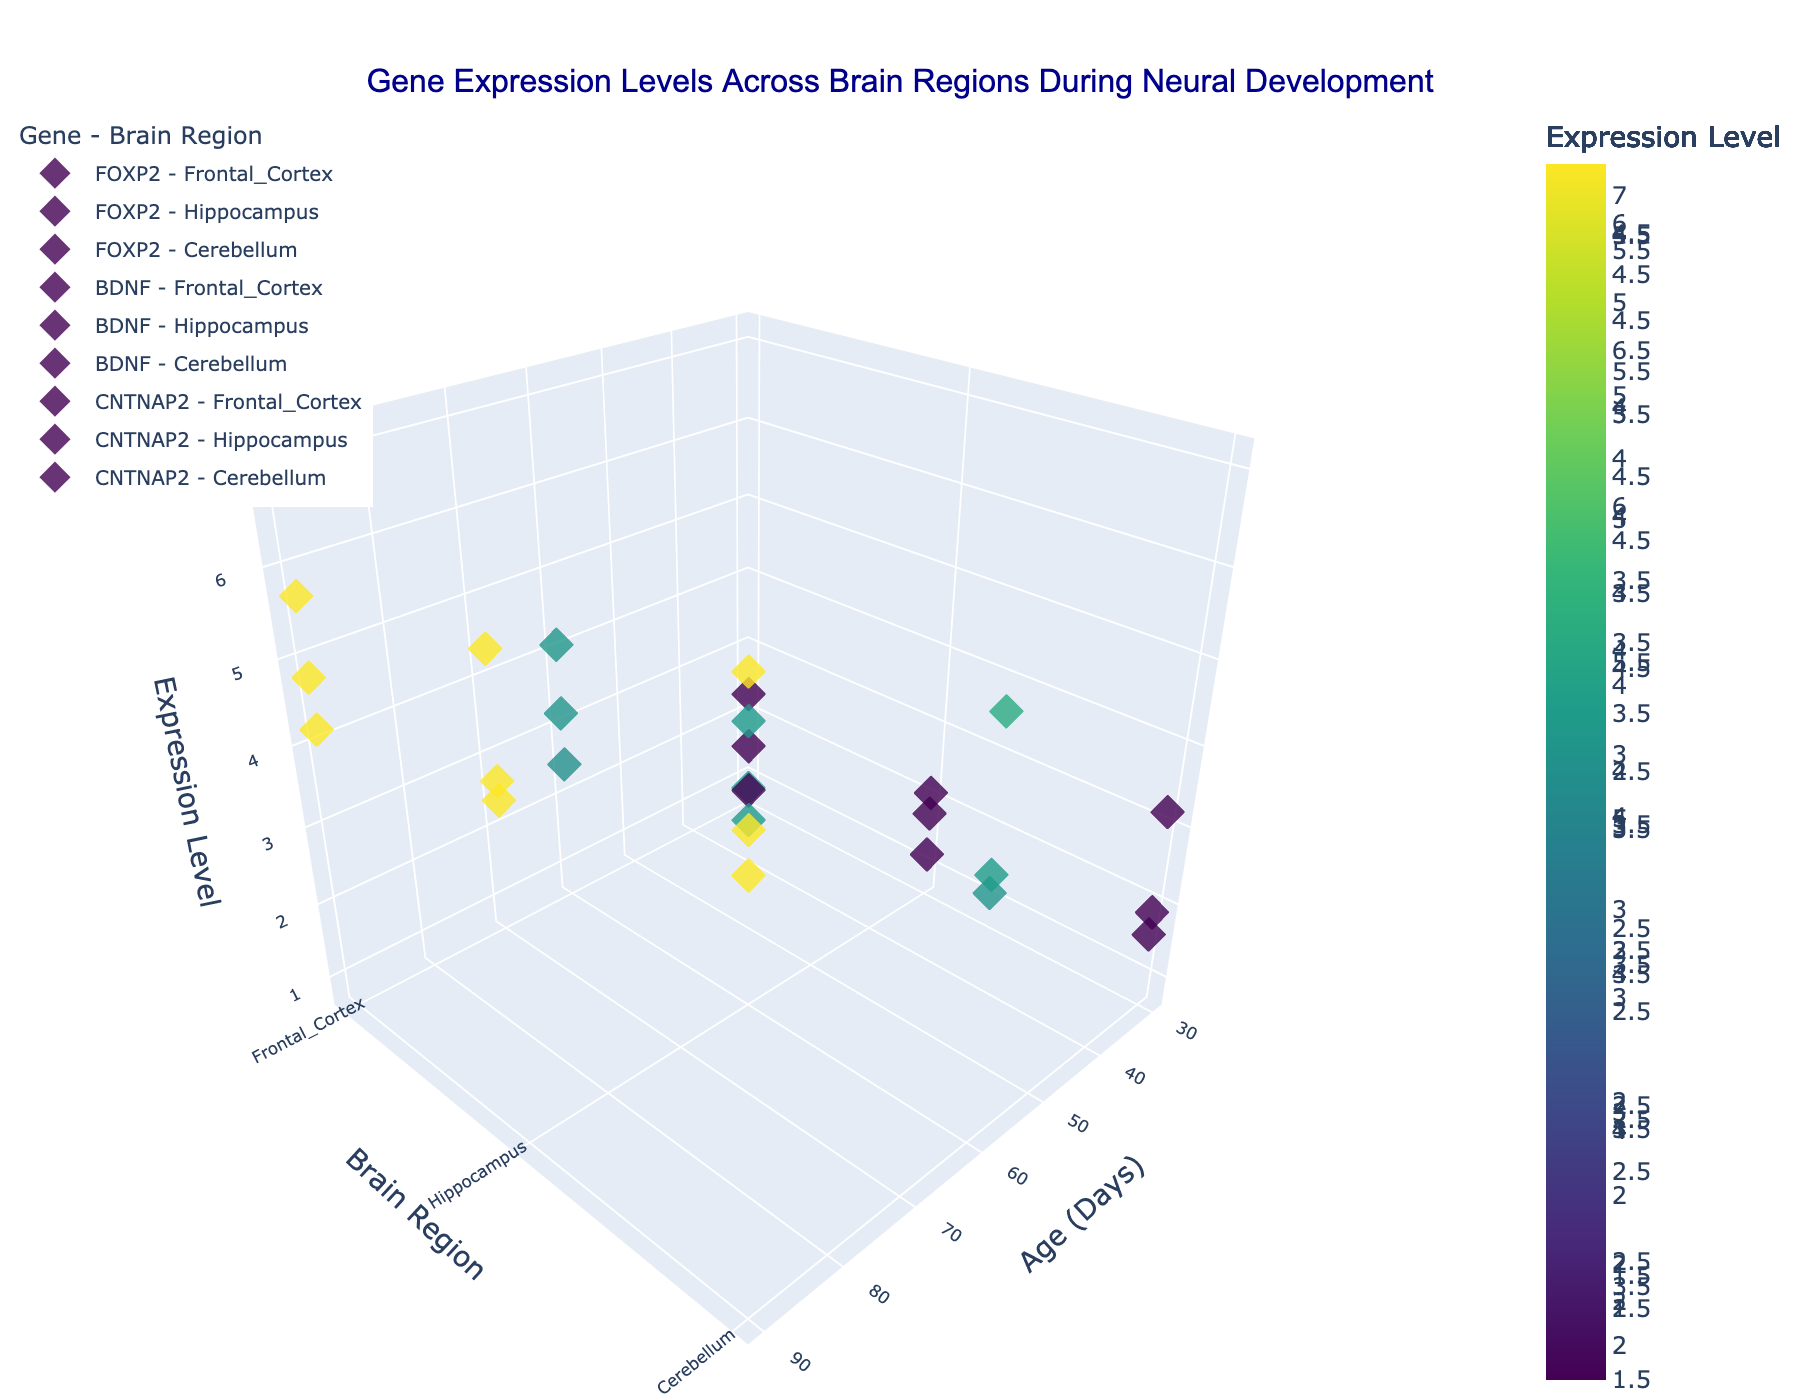what is the title of the figure? The title is usually placed at the top of the figure. In this case, it reads "Gene Expression Levels Across Brain Regions During Neural Development".
Answer: Gene Expression Levels Across Brain Regions During Neural Development What are the three brain regions displayed on the y-axis? The y-axis represents the brain regions. From the figure, the three brain regions are "Frontal Cortex", "Hippocampus", and "Cerebellum".
Answer: Frontal Cortex, Hippocampus, Cerebellum How does FOXP2 expression in the Frontal Cortex change with age? Looking at the markers for FOXP2 in the Frontal Cortex, we see the expression levels at 30 days, 60 days, and 90 days. These levels are 2.3, 4.1, and 5.7 respectively, showing an increasing trend.
Answer: Increases Which gene has the highest expression level in the Cerebellum at 90 days? We need to identify the point at Cerebellum at 90 days and compare the expression levels. FOXP2 has an expression of 7.1, BDNF has 5.4, and CNTNAP2 has 5.8. The highest value is for FOXP2.
Answer: FOXP2 Between which ages does BDNF expression in the Hippocampus grow the fastest? To answer, calculate the differences in expression levels between the age intervals. From 30 to 60 days, BDNF expression increases from 2.1 to 4.3 (a difference of 2.2). From 60 to 90 days, it increases from 4.3 to 6.2 (a difference of 1.9). The largest increase occurs between 30 and 60 days.
Answer: 30 to 60 days Compare the expression levels of CNTNAP2 in the Frontal Cortex and in the Hippocampus at 60 days. Observe the expression levels at 60 days for both regions: in the Frontal Cortex, CNTNAP2 level is 2.5, while in the Hippocampus, it is 3.1. The level in the Hippocampus is higher than in the Frontal Cortex at 60 days.
Answer: Higher in Hippocampus How does the gene expression pattern of BDNF in the Hippocampus compare with that in the Cerebellum over time? Look at BDNF levels in both regions at 30, 60, and 90 days. In the Hippocampus, the levels are 2.1, 4.3, and 6.2. In the Cerebellum, they are 1.9, 3.7, and 5.4. Both genes show increasing expression over time with similar upward trends, but the levels are consistently higher in the Hippocampus.
Answer: Both increase, higher in Hippocampus Which brain region exhibits the highest general trend of gene expression for CNTNAP2? By comparing CNTNAP2 expression across different regions (look at z-values), the Cerebellum displays the highest overall values at all time points (1.6, 3.9, 5.8).
Answer: Cerebellum What is the expression level difference between FOXP2 and BDNF in the Frontal Cortex at 90 days? The expression levels of FOXP2 and BDNF in the Frontal Cortex at 90 days are 5.7 and 4.8 respectively. The difference is 5.7 - 4.8 = 0.9.
Answer: 0.9 